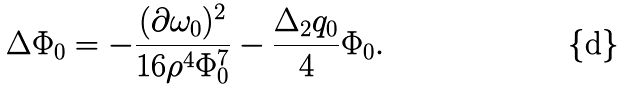Convert formula to latex. <formula><loc_0><loc_0><loc_500><loc_500>\Delta \Phi _ { 0 } = - \frac { ( \partial \omega _ { 0 } ) ^ { 2 } } { 1 6 \rho ^ { 4 } \Phi _ { 0 } ^ { 7 } } - \frac { \Delta _ { 2 } q _ { 0 } } { 4 } \Phi _ { 0 } .</formula> 